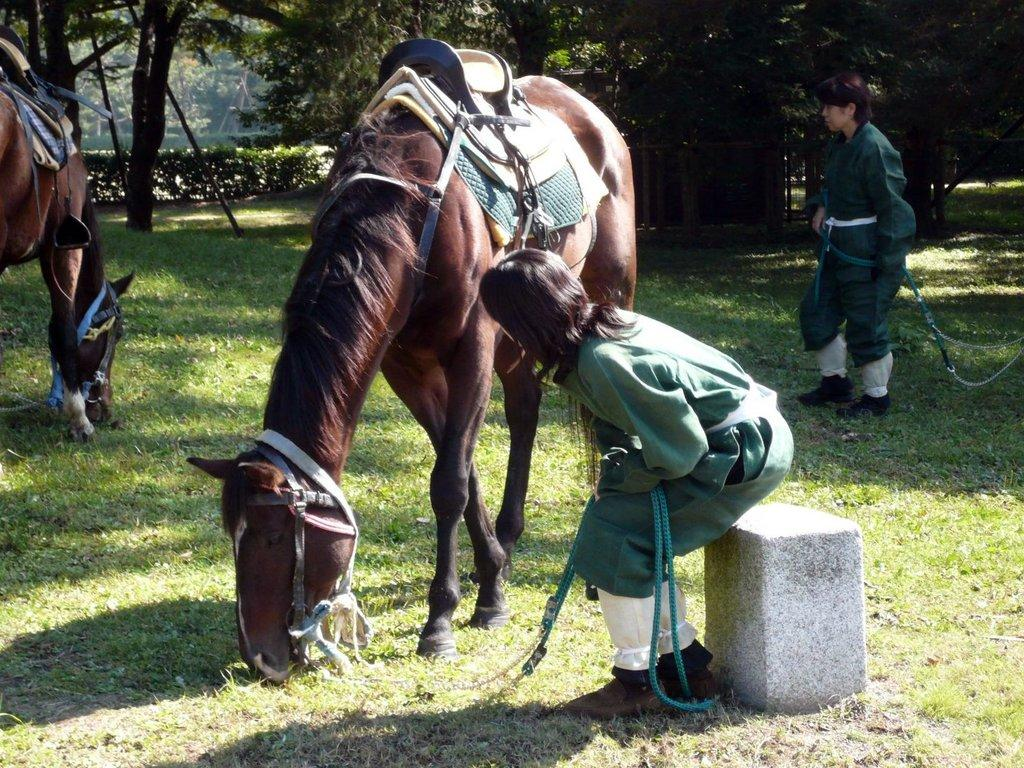Where was the image taken? The image was taken outside a ground. What animals are present in the image? There are two horses in the image. How many people are in the image? There are two persons in the image. What is the ground covered with? The ground is full of grass. What can be seen in the background of the image? There are trees in the background of the image. What type of receipt can be seen in the image? There is no receipt present in the image. What is the condition of the daughter in the image? There is no daughter present in the image. 